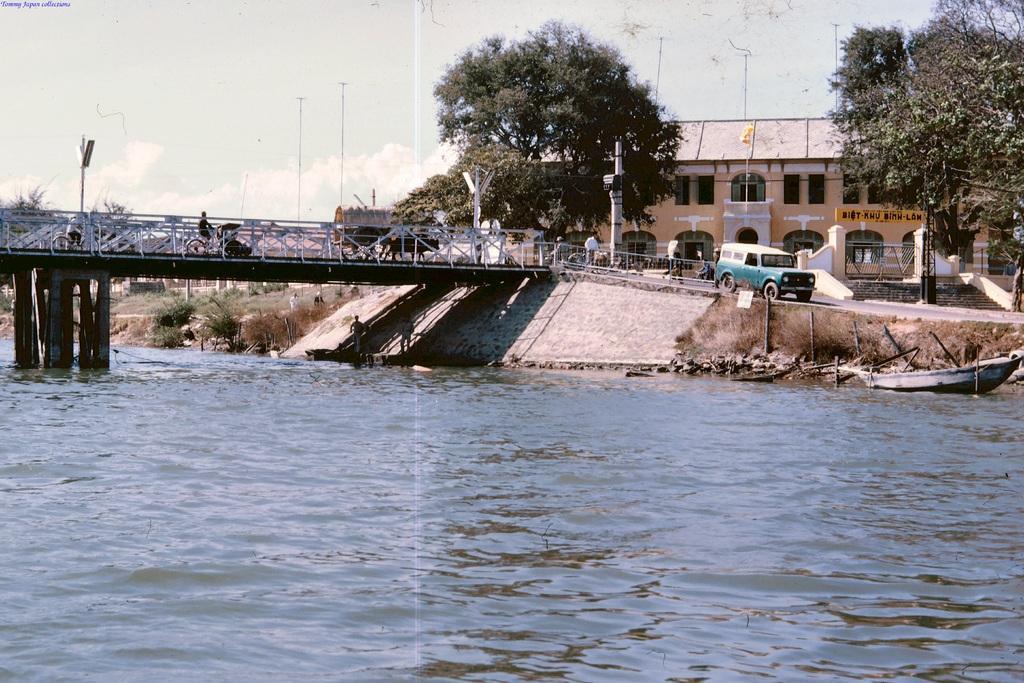In one or two sentences, can you explain what this image depicts? In this image there is a photograph. At the bottom of the image there is water. On the water there is a boat. On the right side of the water there are two persons standing. Above the water there is a bridge with poles and railing. On the bridge there are vehicles, poles with street lights. And on the right side of the image there are steps, gates and pillars. Behind them there is a building with walls, roofs, pillars and windows. And there are many trees. And also there is a road with vehicles. In the background there are plants. At the top of the image there is sky. 